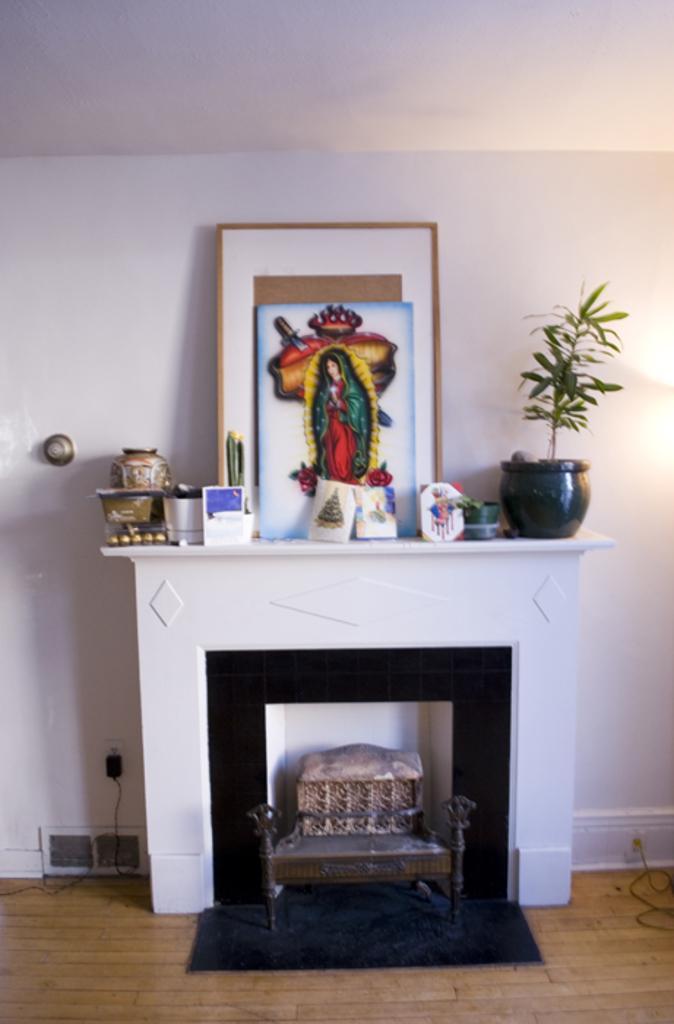Could you give a brief overview of what you see in this image? In the foreground of this image, there is fireplace mantel shelf on which potted plant, few objects, photos frames on it. In the background, there is a white wall. On the bottom, on either side there are cables on the floor and under the shelf, we can see few objects. 